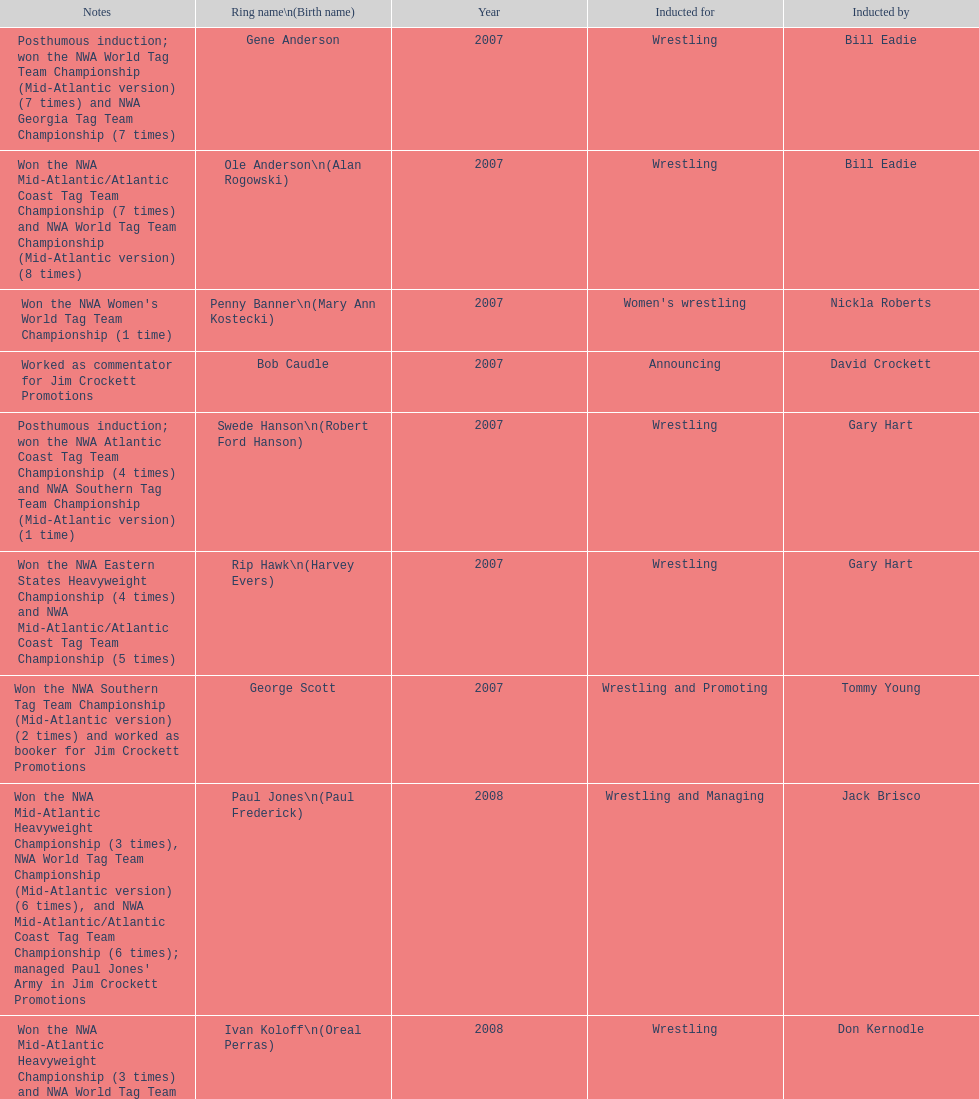I'm looking to parse the entire table for insights. Could you assist me with that? {'header': ['Notes', 'Ring name\\n(Birth name)', 'Year', 'Inducted for', 'Inducted by'], 'rows': [['Posthumous induction; won the NWA World Tag Team Championship (Mid-Atlantic version) (7 times) and NWA Georgia Tag Team Championship (7 times)', 'Gene Anderson', '2007', 'Wrestling', 'Bill Eadie'], ['Won the NWA Mid-Atlantic/Atlantic Coast Tag Team Championship (7 times) and NWA World Tag Team Championship (Mid-Atlantic version) (8 times)', 'Ole Anderson\\n(Alan Rogowski)', '2007', 'Wrestling', 'Bill Eadie'], ["Won the NWA Women's World Tag Team Championship (1 time)", 'Penny Banner\\n(Mary Ann Kostecki)', '2007', "Women's wrestling", 'Nickla Roberts'], ['Worked as commentator for Jim Crockett Promotions', 'Bob Caudle', '2007', 'Announcing', 'David Crockett'], ['Posthumous induction; won the NWA Atlantic Coast Tag Team Championship (4 times) and NWA Southern Tag Team Championship (Mid-Atlantic version) (1 time)', 'Swede Hanson\\n(Robert Ford Hanson)', '2007', 'Wrestling', 'Gary Hart'], ['Won the NWA Eastern States Heavyweight Championship (4 times) and NWA Mid-Atlantic/Atlantic Coast Tag Team Championship (5 times)', 'Rip Hawk\\n(Harvey Evers)', '2007', 'Wrestling', 'Gary Hart'], ['Won the NWA Southern Tag Team Championship (Mid-Atlantic version) (2 times) and worked as booker for Jim Crockett Promotions', 'George Scott', '2007', 'Wrestling and Promoting', 'Tommy Young'], ["Won the NWA Mid-Atlantic Heavyweight Championship (3 times), NWA World Tag Team Championship (Mid-Atlantic version) (6 times), and NWA Mid-Atlantic/Atlantic Coast Tag Team Championship (6 times); managed Paul Jones' Army in Jim Crockett Promotions", 'Paul Jones\\n(Paul Frederick)', '2008', 'Wrestling and Managing', 'Jack Brisco'], ['Won the NWA Mid-Atlantic Heavyweight Championship (3 times) and NWA World Tag Team Championship (Mid-Atlantic version) (4 times)', 'Ivan Koloff\\n(Oreal Perras)', '2008', 'Wrestling', 'Don Kernodle'], ['Won the NWA Georgia Tag Team Championship (3 times) and NWA Atlantic Coast Tag Team Championship (1 time)', 'Thunderbolt Patterson\\n(Claude Patterson)', '2008', 'Wrestling', 'Ole Anderson'], ['Won the NWA World Six-Man Tag Team Championship (Texas version) / WCWA World Six-Man Tag Team Championship (6 times) and NWA Mid-Atlantic Tag Team Championship (1 time)', 'Buddy Roberts\\n(Dale Hey)', '2008', 'Wrestling', 'Jimmy Garvin and Michael Hayes'], ['Worked as an executive for Jim Crockett Promotions and won the NWA World Tag Team Championship (Central States version) (1 time) and NWA Southern Tag Team Championship (Mid-Atlantic version) (3 times)', 'Sandy Scott\\n(Angus Mackay Scott)', '2008', 'Wrestling and Promoting', 'Bob Caudle'], ['Won the NWA United States Tag Team Championship (Tri-State version) (2 times) and NWA Texas Heavyweight Championship (1 time)', 'Grizzly Smith\\n(Aurelian Smith)', '2008', 'Wrestling', 'Magnum T.A.'], ['Posthumous induction; won the NWA Atlantic Coast/Mid-Atlantic Tag Team Championship (8 times) and NWA Southern Tag Team Championship (Mid-Atlantic version) (6 times)', 'Johnny Weaver\\n(Kenneth Eugene Weaver)', '2008', 'Wrestling', 'Rip Hawk'], ['Won the NWA Southern Tag Team Championship (Mid-America version) (2 times) and NWA World Tag Team Championship (Mid-America version) (6 times)', 'Don Fargo\\n(Don Kalt)', '2009', 'Wrestling', 'Jerry Jarrett & Steve Keirn'], ['Won the NWA World Tag Team Championship (Mid-America version) (10 times) and NWA Southern Tag Team Championship (Mid-America version) (22 times)', 'Jackie Fargo\\n(Henry Faggart)', '2009', 'Wrestling', 'Jerry Jarrett & Steve Keirn'], ['Posthumous induction; won the NWA Southern Tag Team Championship (Mid-America version) (3 times)', 'Sonny Fargo\\n(Jack Lewis Faggart)', '2009', 'Wrestling', 'Jerry Jarrett & Steve Keirn'], ['Posthumous induction; worked as a booker in World Class Championship Wrestling and managed several wrestlers in Mid-Atlantic Championship Wrestling', 'Gary Hart\\n(Gary Williams)', '2009', 'Managing and Promoting', 'Sir Oliver Humperdink'], ['Posthumous induction; won the NWA Mid-Atlantic Heavyweight Championship (6 times) and NWA World Tag Team Championship (Mid-Atlantic version) (4 times)', 'Wahoo McDaniel\\n(Edward McDaniel)', '2009', 'Wrestling', 'Tully Blanchard'], ['Won the NWA Texas Heavyweight Championship (1 time) and NWA World Tag Team Championship (Mid-Atlantic version) (1 time)', 'Blackjack Mulligan\\n(Robert Windham)', '2009', 'Wrestling', 'Ric Flair'], ['Won the NWA Atlantic Coast Tag Team Championship (2 times)', 'Nelson Royal', '2009', 'Wrestling', 'Brad Anderson, Tommy Angel & David Isley'], ['Worked as commentator for wrestling events in the Memphis area', 'Lance Russell', '2009', 'Announcing', 'Dave Brown']]} Who won the most nwa southern tag team championships (mid-america version)? Jackie Fargo. 